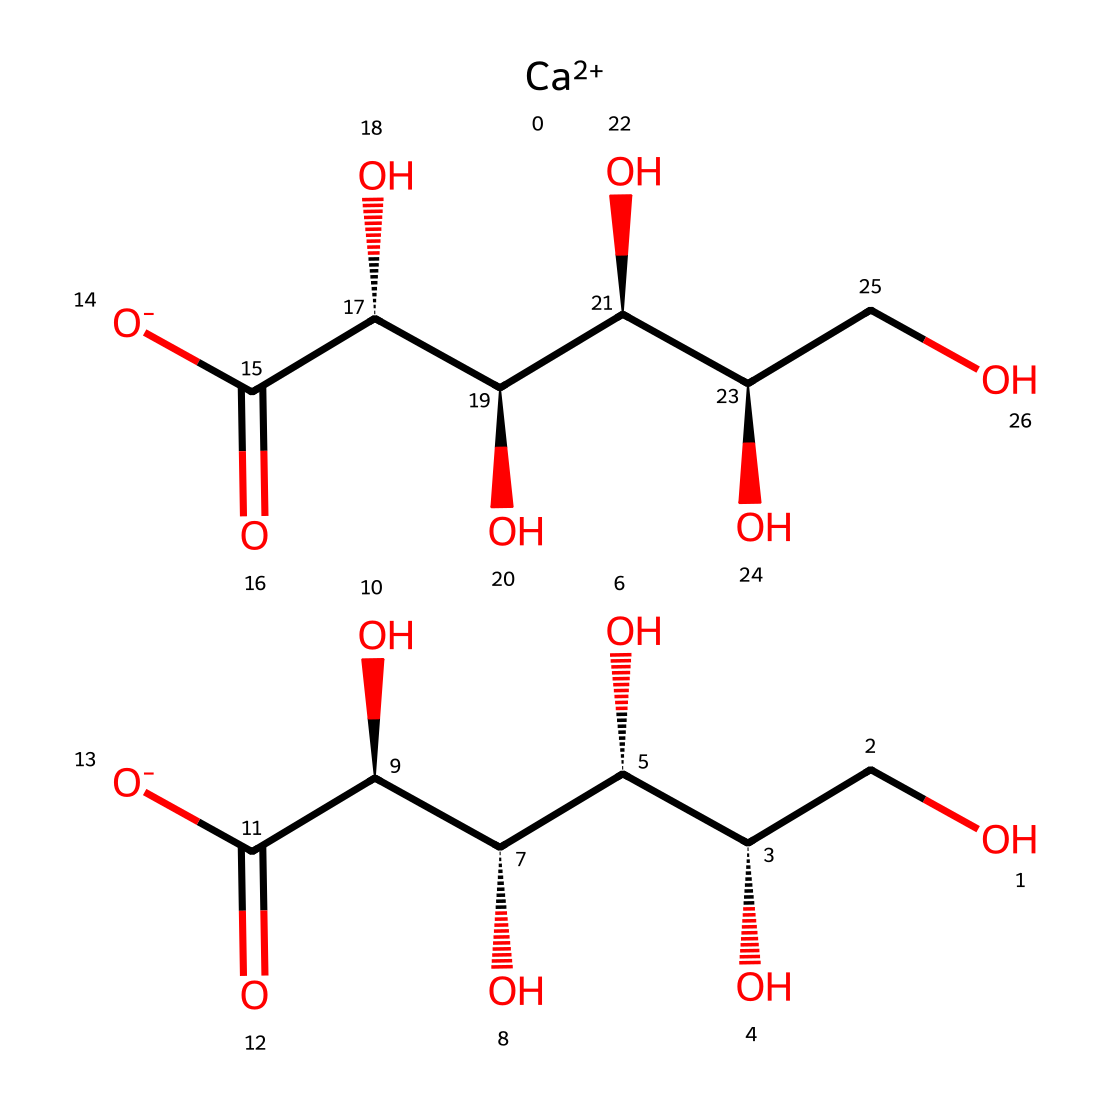What is the central metal ion in this compound? The structure includes [Ca++] as part of its representation, indicating that calcium is the central metal ion.
Answer: calcium How many hydroxyl (-OH) groups are present in the structure? The structure contains five carbon atoms connected by hydroxyl (-OH) groups, which can be counted directly from the carbon atoms that have these groups attached.
Answer: five What type of chemical compound is calcium gluconate classified as? Given its composition of calcium, glucose-derived sections, and the presence of carboxylate groups, it is classified as a calcium salt of gluconic acid.
Answer: calcium salt What are the total carbon (C) atoms present in the compound? By examining the structure, there are a total of nine carbon atoms: five from the gluconate part and four from the additional glucose-derived section.
Answer: nine What role does calcium gluconate play in hydration formulas? As an electrolyte, calcium gluconate is used to replenish electrolyte levels in the body, aiding in hydration especially during prolonged physical activities like marathons or ultramarathons.
Answer: electrolyte Which functional groups are present besides the carboxylate group? Apart from carboxylate groups (-COO-), the structure exhibits multiple hydroxyl (-OH) groups, contributing to its functionality as a sugar acid.
Answer: hydroxyl groups 